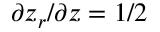Convert formula to latex. <formula><loc_0><loc_0><loc_500><loc_500>\partial z _ { r } / \partial z = 1 / 2</formula> 